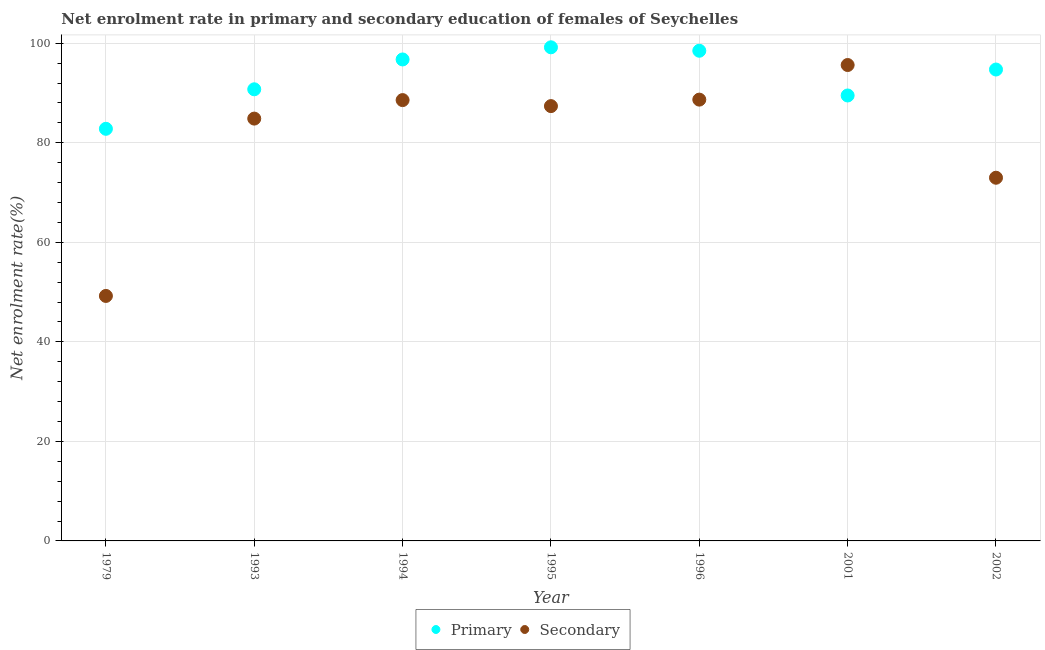How many different coloured dotlines are there?
Ensure brevity in your answer.  2. What is the enrollment rate in secondary education in 1993?
Ensure brevity in your answer.  84.86. Across all years, what is the maximum enrollment rate in secondary education?
Provide a succinct answer. 95.63. Across all years, what is the minimum enrollment rate in secondary education?
Make the answer very short. 49.23. In which year was the enrollment rate in primary education minimum?
Your answer should be compact. 1979. What is the total enrollment rate in secondary education in the graph?
Offer a terse response. 567.31. What is the difference between the enrollment rate in primary education in 1994 and that in 2001?
Offer a very short reply. 7.24. What is the difference between the enrollment rate in primary education in 1994 and the enrollment rate in secondary education in 1996?
Keep it short and to the point. 8.07. What is the average enrollment rate in secondary education per year?
Your answer should be very brief. 81.04. In the year 1979, what is the difference between the enrollment rate in primary education and enrollment rate in secondary education?
Give a very brief answer. 33.58. In how many years, is the enrollment rate in secondary education greater than 64 %?
Make the answer very short. 6. What is the ratio of the enrollment rate in secondary education in 1993 to that in 1994?
Provide a succinct answer. 0.96. Is the enrollment rate in primary education in 1993 less than that in 1995?
Give a very brief answer. Yes. Is the difference between the enrollment rate in secondary education in 1979 and 2002 greater than the difference between the enrollment rate in primary education in 1979 and 2002?
Your response must be concise. No. What is the difference between the highest and the second highest enrollment rate in primary education?
Your answer should be very brief. 0.69. What is the difference between the highest and the lowest enrollment rate in secondary education?
Give a very brief answer. 46.4. In how many years, is the enrollment rate in secondary education greater than the average enrollment rate in secondary education taken over all years?
Ensure brevity in your answer.  5. Is the enrollment rate in primary education strictly less than the enrollment rate in secondary education over the years?
Offer a terse response. No. How many dotlines are there?
Ensure brevity in your answer.  2. How many years are there in the graph?
Make the answer very short. 7. What is the difference between two consecutive major ticks on the Y-axis?
Give a very brief answer. 20. How are the legend labels stacked?
Ensure brevity in your answer.  Horizontal. What is the title of the graph?
Ensure brevity in your answer.  Net enrolment rate in primary and secondary education of females of Seychelles. What is the label or title of the Y-axis?
Your response must be concise. Net enrolment rate(%). What is the Net enrolment rate(%) in Primary in 1979?
Your response must be concise. 82.81. What is the Net enrolment rate(%) in Secondary in 1979?
Give a very brief answer. 49.23. What is the Net enrolment rate(%) of Primary in 1993?
Offer a very short reply. 90.75. What is the Net enrolment rate(%) of Secondary in 1993?
Keep it short and to the point. 84.86. What is the Net enrolment rate(%) of Primary in 1994?
Give a very brief answer. 96.74. What is the Net enrolment rate(%) of Secondary in 1994?
Make the answer very short. 88.58. What is the Net enrolment rate(%) in Primary in 1995?
Provide a succinct answer. 99.19. What is the Net enrolment rate(%) of Secondary in 1995?
Your answer should be very brief. 87.37. What is the Net enrolment rate(%) in Primary in 1996?
Make the answer very short. 98.49. What is the Net enrolment rate(%) of Secondary in 1996?
Your response must be concise. 88.67. What is the Net enrolment rate(%) of Primary in 2001?
Your answer should be compact. 89.51. What is the Net enrolment rate(%) in Secondary in 2001?
Make the answer very short. 95.63. What is the Net enrolment rate(%) in Primary in 2002?
Keep it short and to the point. 94.72. What is the Net enrolment rate(%) in Secondary in 2002?
Your response must be concise. 72.98. Across all years, what is the maximum Net enrolment rate(%) in Primary?
Keep it short and to the point. 99.19. Across all years, what is the maximum Net enrolment rate(%) of Secondary?
Your answer should be very brief. 95.63. Across all years, what is the minimum Net enrolment rate(%) in Primary?
Give a very brief answer. 82.81. Across all years, what is the minimum Net enrolment rate(%) in Secondary?
Your response must be concise. 49.23. What is the total Net enrolment rate(%) in Primary in the graph?
Your response must be concise. 652.21. What is the total Net enrolment rate(%) of Secondary in the graph?
Your answer should be very brief. 567.31. What is the difference between the Net enrolment rate(%) of Primary in 1979 and that in 1993?
Provide a succinct answer. -7.94. What is the difference between the Net enrolment rate(%) of Secondary in 1979 and that in 1993?
Your response must be concise. -35.63. What is the difference between the Net enrolment rate(%) of Primary in 1979 and that in 1994?
Your answer should be very brief. -13.94. What is the difference between the Net enrolment rate(%) of Secondary in 1979 and that in 1994?
Offer a terse response. -39.35. What is the difference between the Net enrolment rate(%) of Primary in 1979 and that in 1995?
Your response must be concise. -16.38. What is the difference between the Net enrolment rate(%) of Secondary in 1979 and that in 1995?
Keep it short and to the point. -38.14. What is the difference between the Net enrolment rate(%) in Primary in 1979 and that in 1996?
Offer a terse response. -15.69. What is the difference between the Net enrolment rate(%) of Secondary in 1979 and that in 1996?
Offer a terse response. -39.45. What is the difference between the Net enrolment rate(%) of Primary in 1979 and that in 2001?
Provide a short and direct response. -6.7. What is the difference between the Net enrolment rate(%) of Secondary in 1979 and that in 2001?
Give a very brief answer. -46.4. What is the difference between the Net enrolment rate(%) of Primary in 1979 and that in 2002?
Ensure brevity in your answer.  -11.91. What is the difference between the Net enrolment rate(%) of Secondary in 1979 and that in 2002?
Provide a short and direct response. -23.75. What is the difference between the Net enrolment rate(%) of Primary in 1993 and that in 1994?
Your response must be concise. -6. What is the difference between the Net enrolment rate(%) in Secondary in 1993 and that in 1994?
Provide a succinct answer. -3.72. What is the difference between the Net enrolment rate(%) in Primary in 1993 and that in 1995?
Make the answer very short. -8.44. What is the difference between the Net enrolment rate(%) in Secondary in 1993 and that in 1995?
Provide a short and direct response. -2.51. What is the difference between the Net enrolment rate(%) in Primary in 1993 and that in 1996?
Keep it short and to the point. -7.75. What is the difference between the Net enrolment rate(%) in Secondary in 1993 and that in 1996?
Provide a succinct answer. -3.81. What is the difference between the Net enrolment rate(%) in Primary in 1993 and that in 2001?
Offer a terse response. 1.24. What is the difference between the Net enrolment rate(%) of Secondary in 1993 and that in 2001?
Provide a short and direct response. -10.77. What is the difference between the Net enrolment rate(%) in Primary in 1993 and that in 2002?
Your answer should be compact. -3.97. What is the difference between the Net enrolment rate(%) in Secondary in 1993 and that in 2002?
Ensure brevity in your answer.  11.88. What is the difference between the Net enrolment rate(%) of Primary in 1994 and that in 1995?
Give a very brief answer. -2.44. What is the difference between the Net enrolment rate(%) in Secondary in 1994 and that in 1995?
Give a very brief answer. 1.21. What is the difference between the Net enrolment rate(%) of Primary in 1994 and that in 1996?
Offer a very short reply. -1.75. What is the difference between the Net enrolment rate(%) in Secondary in 1994 and that in 1996?
Keep it short and to the point. -0.1. What is the difference between the Net enrolment rate(%) in Primary in 1994 and that in 2001?
Your answer should be compact. 7.24. What is the difference between the Net enrolment rate(%) of Secondary in 1994 and that in 2001?
Make the answer very short. -7.05. What is the difference between the Net enrolment rate(%) in Primary in 1994 and that in 2002?
Provide a short and direct response. 2.02. What is the difference between the Net enrolment rate(%) in Secondary in 1994 and that in 2002?
Provide a succinct answer. 15.6. What is the difference between the Net enrolment rate(%) of Primary in 1995 and that in 1996?
Offer a very short reply. 0.69. What is the difference between the Net enrolment rate(%) in Secondary in 1995 and that in 1996?
Make the answer very short. -1.3. What is the difference between the Net enrolment rate(%) in Primary in 1995 and that in 2001?
Keep it short and to the point. 9.68. What is the difference between the Net enrolment rate(%) of Secondary in 1995 and that in 2001?
Offer a terse response. -8.26. What is the difference between the Net enrolment rate(%) in Primary in 1995 and that in 2002?
Give a very brief answer. 4.46. What is the difference between the Net enrolment rate(%) of Secondary in 1995 and that in 2002?
Offer a very short reply. 14.39. What is the difference between the Net enrolment rate(%) in Primary in 1996 and that in 2001?
Ensure brevity in your answer.  8.99. What is the difference between the Net enrolment rate(%) in Secondary in 1996 and that in 2001?
Your answer should be very brief. -6.95. What is the difference between the Net enrolment rate(%) of Primary in 1996 and that in 2002?
Offer a terse response. 3.77. What is the difference between the Net enrolment rate(%) of Secondary in 1996 and that in 2002?
Ensure brevity in your answer.  15.7. What is the difference between the Net enrolment rate(%) of Primary in 2001 and that in 2002?
Your response must be concise. -5.22. What is the difference between the Net enrolment rate(%) of Secondary in 2001 and that in 2002?
Your response must be concise. 22.65. What is the difference between the Net enrolment rate(%) in Primary in 1979 and the Net enrolment rate(%) in Secondary in 1993?
Provide a succinct answer. -2.05. What is the difference between the Net enrolment rate(%) of Primary in 1979 and the Net enrolment rate(%) of Secondary in 1994?
Make the answer very short. -5.77. What is the difference between the Net enrolment rate(%) of Primary in 1979 and the Net enrolment rate(%) of Secondary in 1995?
Give a very brief answer. -4.56. What is the difference between the Net enrolment rate(%) in Primary in 1979 and the Net enrolment rate(%) in Secondary in 1996?
Make the answer very short. -5.86. What is the difference between the Net enrolment rate(%) in Primary in 1979 and the Net enrolment rate(%) in Secondary in 2001?
Offer a very short reply. -12.82. What is the difference between the Net enrolment rate(%) in Primary in 1979 and the Net enrolment rate(%) in Secondary in 2002?
Your answer should be compact. 9.83. What is the difference between the Net enrolment rate(%) of Primary in 1993 and the Net enrolment rate(%) of Secondary in 1994?
Ensure brevity in your answer.  2.17. What is the difference between the Net enrolment rate(%) in Primary in 1993 and the Net enrolment rate(%) in Secondary in 1995?
Your answer should be compact. 3.38. What is the difference between the Net enrolment rate(%) in Primary in 1993 and the Net enrolment rate(%) in Secondary in 1996?
Give a very brief answer. 2.07. What is the difference between the Net enrolment rate(%) in Primary in 1993 and the Net enrolment rate(%) in Secondary in 2001?
Provide a succinct answer. -4.88. What is the difference between the Net enrolment rate(%) in Primary in 1993 and the Net enrolment rate(%) in Secondary in 2002?
Offer a very short reply. 17.77. What is the difference between the Net enrolment rate(%) in Primary in 1994 and the Net enrolment rate(%) in Secondary in 1995?
Provide a succinct answer. 9.37. What is the difference between the Net enrolment rate(%) of Primary in 1994 and the Net enrolment rate(%) of Secondary in 1996?
Provide a succinct answer. 8.07. What is the difference between the Net enrolment rate(%) of Primary in 1994 and the Net enrolment rate(%) of Secondary in 2001?
Your response must be concise. 1.12. What is the difference between the Net enrolment rate(%) in Primary in 1994 and the Net enrolment rate(%) in Secondary in 2002?
Provide a succinct answer. 23.77. What is the difference between the Net enrolment rate(%) in Primary in 1995 and the Net enrolment rate(%) in Secondary in 1996?
Provide a short and direct response. 10.51. What is the difference between the Net enrolment rate(%) in Primary in 1995 and the Net enrolment rate(%) in Secondary in 2001?
Give a very brief answer. 3.56. What is the difference between the Net enrolment rate(%) of Primary in 1995 and the Net enrolment rate(%) of Secondary in 2002?
Keep it short and to the point. 26.21. What is the difference between the Net enrolment rate(%) in Primary in 1996 and the Net enrolment rate(%) in Secondary in 2001?
Make the answer very short. 2.87. What is the difference between the Net enrolment rate(%) in Primary in 1996 and the Net enrolment rate(%) in Secondary in 2002?
Make the answer very short. 25.52. What is the difference between the Net enrolment rate(%) in Primary in 2001 and the Net enrolment rate(%) in Secondary in 2002?
Give a very brief answer. 16.53. What is the average Net enrolment rate(%) in Primary per year?
Keep it short and to the point. 93.17. What is the average Net enrolment rate(%) in Secondary per year?
Offer a terse response. 81.04. In the year 1979, what is the difference between the Net enrolment rate(%) in Primary and Net enrolment rate(%) in Secondary?
Provide a succinct answer. 33.58. In the year 1993, what is the difference between the Net enrolment rate(%) in Primary and Net enrolment rate(%) in Secondary?
Ensure brevity in your answer.  5.89. In the year 1994, what is the difference between the Net enrolment rate(%) in Primary and Net enrolment rate(%) in Secondary?
Offer a very short reply. 8.17. In the year 1995, what is the difference between the Net enrolment rate(%) in Primary and Net enrolment rate(%) in Secondary?
Offer a terse response. 11.82. In the year 1996, what is the difference between the Net enrolment rate(%) of Primary and Net enrolment rate(%) of Secondary?
Provide a succinct answer. 9.82. In the year 2001, what is the difference between the Net enrolment rate(%) in Primary and Net enrolment rate(%) in Secondary?
Offer a terse response. -6.12. In the year 2002, what is the difference between the Net enrolment rate(%) of Primary and Net enrolment rate(%) of Secondary?
Provide a short and direct response. 21.74. What is the ratio of the Net enrolment rate(%) of Primary in 1979 to that in 1993?
Ensure brevity in your answer.  0.91. What is the ratio of the Net enrolment rate(%) of Secondary in 1979 to that in 1993?
Your answer should be compact. 0.58. What is the ratio of the Net enrolment rate(%) in Primary in 1979 to that in 1994?
Your response must be concise. 0.86. What is the ratio of the Net enrolment rate(%) in Secondary in 1979 to that in 1994?
Give a very brief answer. 0.56. What is the ratio of the Net enrolment rate(%) in Primary in 1979 to that in 1995?
Provide a succinct answer. 0.83. What is the ratio of the Net enrolment rate(%) in Secondary in 1979 to that in 1995?
Ensure brevity in your answer.  0.56. What is the ratio of the Net enrolment rate(%) of Primary in 1979 to that in 1996?
Make the answer very short. 0.84. What is the ratio of the Net enrolment rate(%) of Secondary in 1979 to that in 1996?
Make the answer very short. 0.56. What is the ratio of the Net enrolment rate(%) in Primary in 1979 to that in 2001?
Offer a very short reply. 0.93. What is the ratio of the Net enrolment rate(%) of Secondary in 1979 to that in 2001?
Make the answer very short. 0.51. What is the ratio of the Net enrolment rate(%) of Primary in 1979 to that in 2002?
Keep it short and to the point. 0.87. What is the ratio of the Net enrolment rate(%) of Secondary in 1979 to that in 2002?
Your response must be concise. 0.67. What is the ratio of the Net enrolment rate(%) of Primary in 1993 to that in 1994?
Give a very brief answer. 0.94. What is the ratio of the Net enrolment rate(%) in Secondary in 1993 to that in 1994?
Your answer should be very brief. 0.96. What is the ratio of the Net enrolment rate(%) of Primary in 1993 to that in 1995?
Ensure brevity in your answer.  0.91. What is the ratio of the Net enrolment rate(%) of Secondary in 1993 to that in 1995?
Provide a succinct answer. 0.97. What is the ratio of the Net enrolment rate(%) in Primary in 1993 to that in 1996?
Provide a succinct answer. 0.92. What is the ratio of the Net enrolment rate(%) of Secondary in 1993 to that in 1996?
Provide a short and direct response. 0.96. What is the ratio of the Net enrolment rate(%) in Primary in 1993 to that in 2001?
Your response must be concise. 1.01. What is the ratio of the Net enrolment rate(%) in Secondary in 1993 to that in 2001?
Keep it short and to the point. 0.89. What is the ratio of the Net enrolment rate(%) of Primary in 1993 to that in 2002?
Offer a very short reply. 0.96. What is the ratio of the Net enrolment rate(%) of Secondary in 1993 to that in 2002?
Provide a short and direct response. 1.16. What is the ratio of the Net enrolment rate(%) of Primary in 1994 to that in 1995?
Make the answer very short. 0.98. What is the ratio of the Net enrolment rate(%) of Secondary in 1994 to that in 1995?
Provide a succinct answer. 1.01. What is the ratio of the Net enrolment rate(%) in Primary in 1994 to that in 1996?
Keep it short and to the point. 0.98. What is the ratio of the Net enrolment rate(%) of Secondary in 1994 to that in 1996?
Your answer should be compact. 1. What is the ratio of the Net enrolment rate(%) of Primary in 1994 to that in 2001?
Your answer should be compact. 1.08. What is the ratio of the Net enrolment rate(%) of Secondary in 1994 to that in 2001?
Provide a succinct answer. 0.93. What is the ratio of the Net enrolment rate(%) in Primary in 1994 to that in 2002?
Your response must be concise. 1.02. What is the ratio of the Net enrolment rate(%) of Secondary in 1994 to that in 2002?
Your response must be concise. 1.21. What is the ratio of the Net enrolment rate(%) in Primary in 1995 to that in 1996?
Provide a succinct answer. 1.01. What is the ratio of the Net enrolment rate(%) in Primary in 1995 to that in 2001?
Offer a very short reply. 1.11. What is the ratio of the Net enrolment rate(%) in Secondary in 1995 to that in 2001?
Keep it short and to the point. 0.91. What is the ratio of the Net enrolment rate(%) in Primary in 1995 to that in 2002?
Keep it short and to the point. 1.05. What is the ratio of the Net enrolment rate(%) of Secondary in 1995 to that in 2002?
Offer a very short reply. 1.2. What is the ratio of the Net enrolment rate(%) of Primary in 1996 to that in 2001?
Your answer should be very brief. 1.1. What is the ratio of the Net enrolment rate(%) of Secondary in 1996 to that in 2001?
Your answer should be very brief. 0.93. What is the ratio of the Net enrolment rate(%) in Primary in 1996 to that in 2002?
Your answer should be compact. 1.04. What is the ratio of the Net enrolment rate(%) in Secondary in 1996 to that in 2002?
Your response must be concise. 1.22. What is the ratio of the Net enrolment rate(%) in Primary in 2001 to that in 2002?
Offer a terse response. 0.94. What is the ratio of the Net enrolment rate(%) of Secondary in 2001 to that in 2002?
Provide a succinct answer. 1.31. What is the difference between the highest and the second highest Net enrolment rate(%) in Primary?
Provide a short and direct response. 0.69. What is the difference between the highest and the second highest Net enrolment rate(%) in Secondary?
Give a very brief answer. 6.95. What is the difference between the highest and the lowest Net enrolment rate(%) in Primary?
Your response must be concise. 16.38. What is the difference between the highest and the lowest Net enrolment rate(%) in Secondary?
Provide a succinct answer. 46.4. 